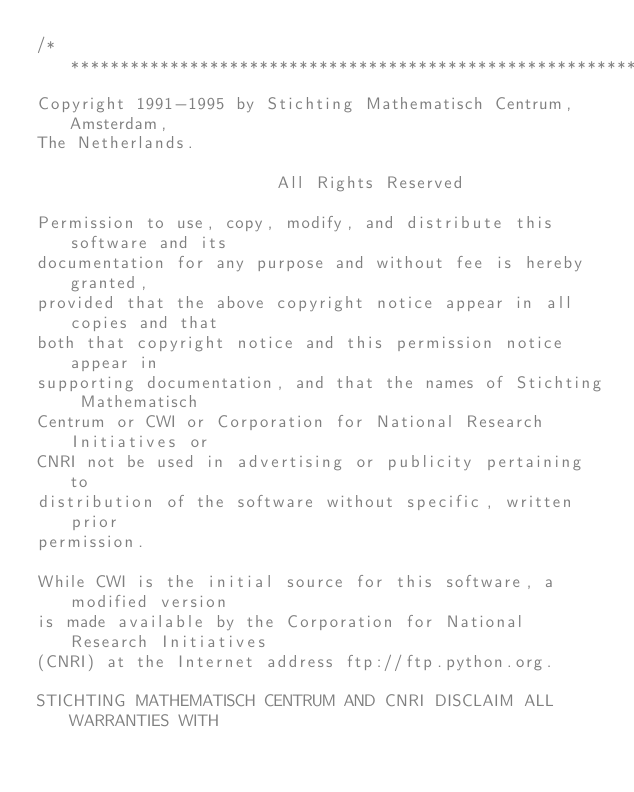Convert code to text. <code><loc_0><loc_0><loc_500><loc_500><_C_>/***********************************************************
Copyright 1991-1995 by Stichting Mathematisch Centrum, Amsterdam,
The Netherlands.

                        All Rights Reserved

Permission to use, copy, modify, and distribute this software and its
documentation for any purpose and without fee is hereby granted,
provided that the above copyright notice appear in all copies and that
both that copyright notice and this permission notice appear in
supporting documentation, and that the names of Stichting Mathematisch
Centrum or CWI or Corporation for National Research Initiatives or
CNRI not be used in advertising or publicity pertaining to
distribution of the software without specific, written prior
permission.

While CWI is the initial source for this software, a modified version
is made available by the Corporation for National Research Initiatives
(CNRI) at the Internet address ftp://ftp.python.org.

STICHTING MATHEMATISCH CENTRUM AND CNRI DISCLAIM ALL WARRANTIES WITH</code> 